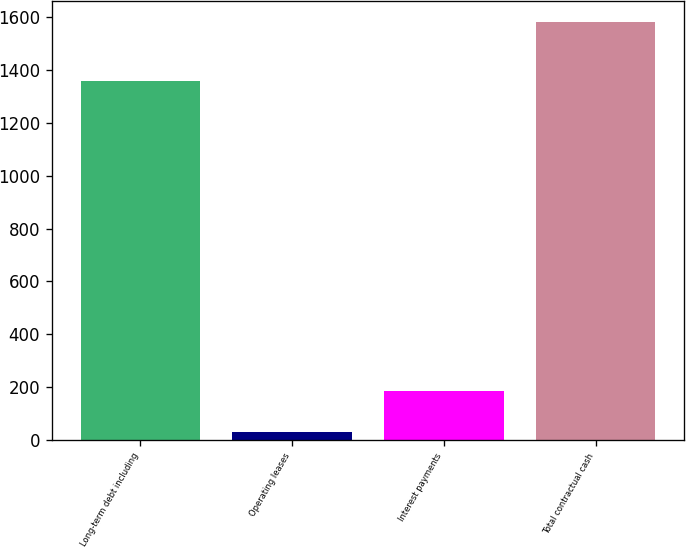Convert chart to OTSL. <chart><loc_0><loc_0><loc_500><loc_500><bar_chart><fcel>Long-term debt including<fcel>Operating leases<fcel>Interest payments<fcel>Total contractual cash<nl><fcel>1359.4<fcel>31.4<fcel>186.6<fcel>1583.4<nl></chart> 